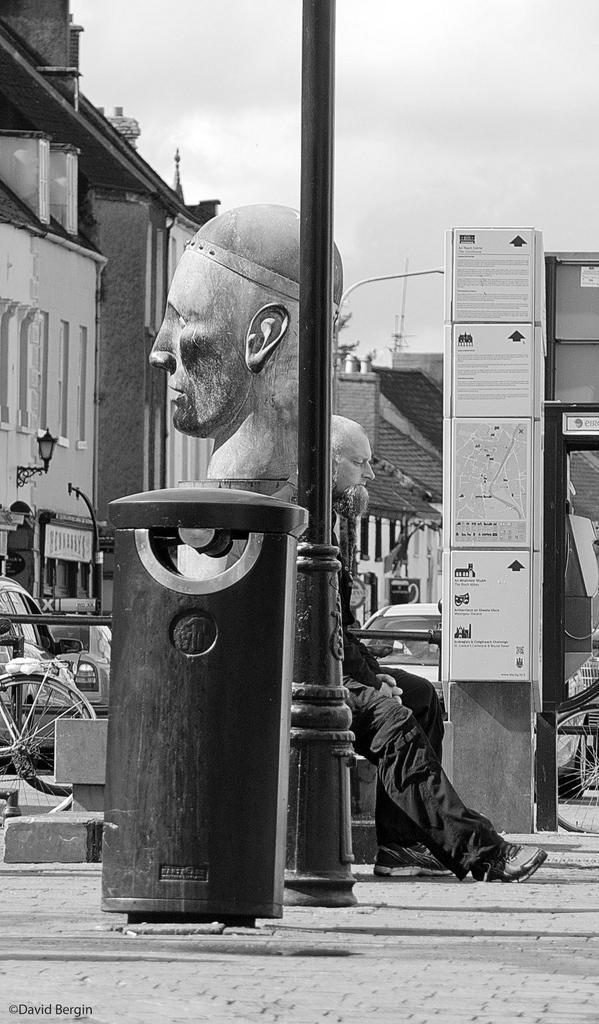Could you give a brief overview of what you see in this image? In this image I can see a person wearing black dress, a statue of a person's head, a bin, a pole and a bicycle. In the background I can see few vehicles on the road, the sidewalk, few buildings and the sky. 